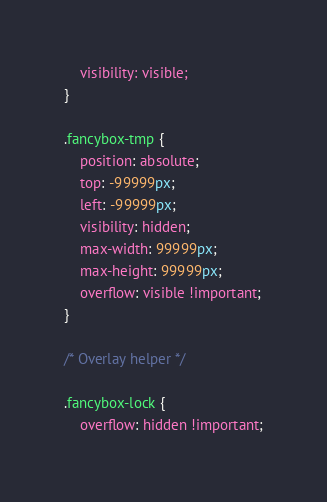Convert code to text. <code><loc_0><loc_0><loc_500><loc_500><_CSS_>	visibility: visible;
}

.fancybox-tmp {
	position: absolute;
	top: -99999px;
	left: -99999px;
	visibility: hidden;
	max-width: 99999px;
	max-height: 99999px;
	overflow: visible !important;
}

/* Overlay helper */

.fancybox-lock {
    overflow: hidden !important;</code> 